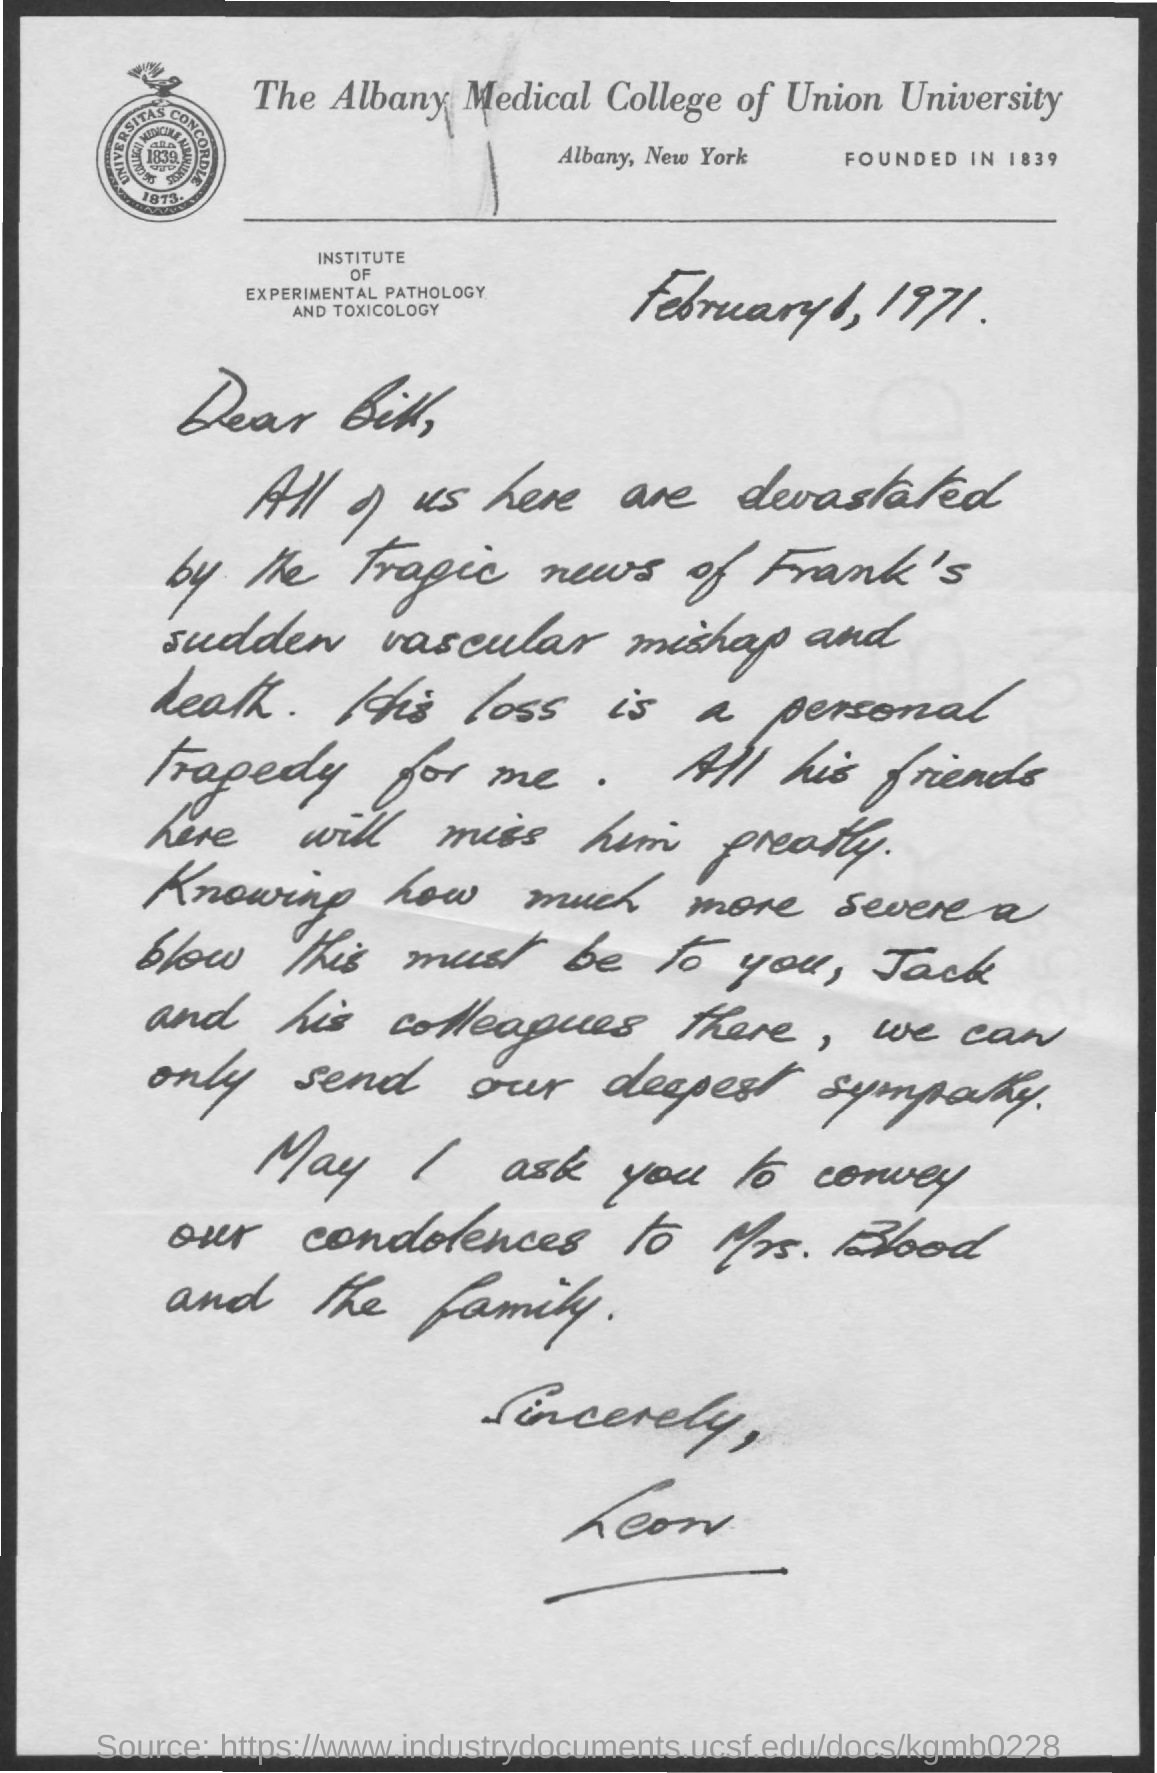Which university is mentioned in the letter head?
Your response must be concise. THE ALBANY MEDICAL COLLEGE OF UNION UNIVERSITY. When was the The Albany Medical College of Union University founded?
Offer a terse response. FOUNDED IN 1839. Who is the addressee of this letter?
Ensure brevity in your answer.  Bill. What is the letter dated?
Your answer should be compact. February 1, 1971. Who is the sender of this letter?
Make the answer very short. Leon. 